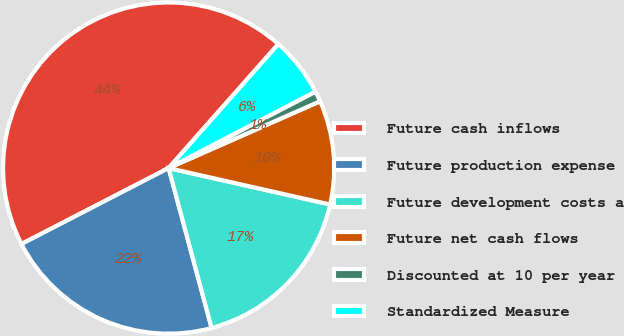Convert chart to OTSL. <chart><loc_0><loc_0><loc_500><loc_500><pie_chart><fcel>Future cash inflows<fcel>Future production expense<fcel>Future development costs a<fcel>Future net cash flows<fcel>Discounted at 10 per year<fcel>Standardized Measure<nl><fcel>44.11%<fcel>21.6%<fcel>17.29%<fcel>10.14%<fcel>1.03%<fcel>5.83%<nl></chart> 